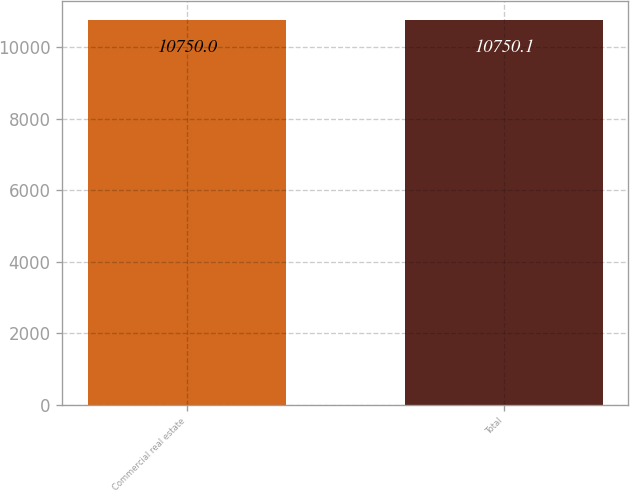Convert chart to OTSL. <chart><loc_0><loc_0><loc_500><loc_500><bar_chart><fcel>Commercial real estate<fcel>Total<nl><fcel>10750<fcel>10750.1<nl></chart> 